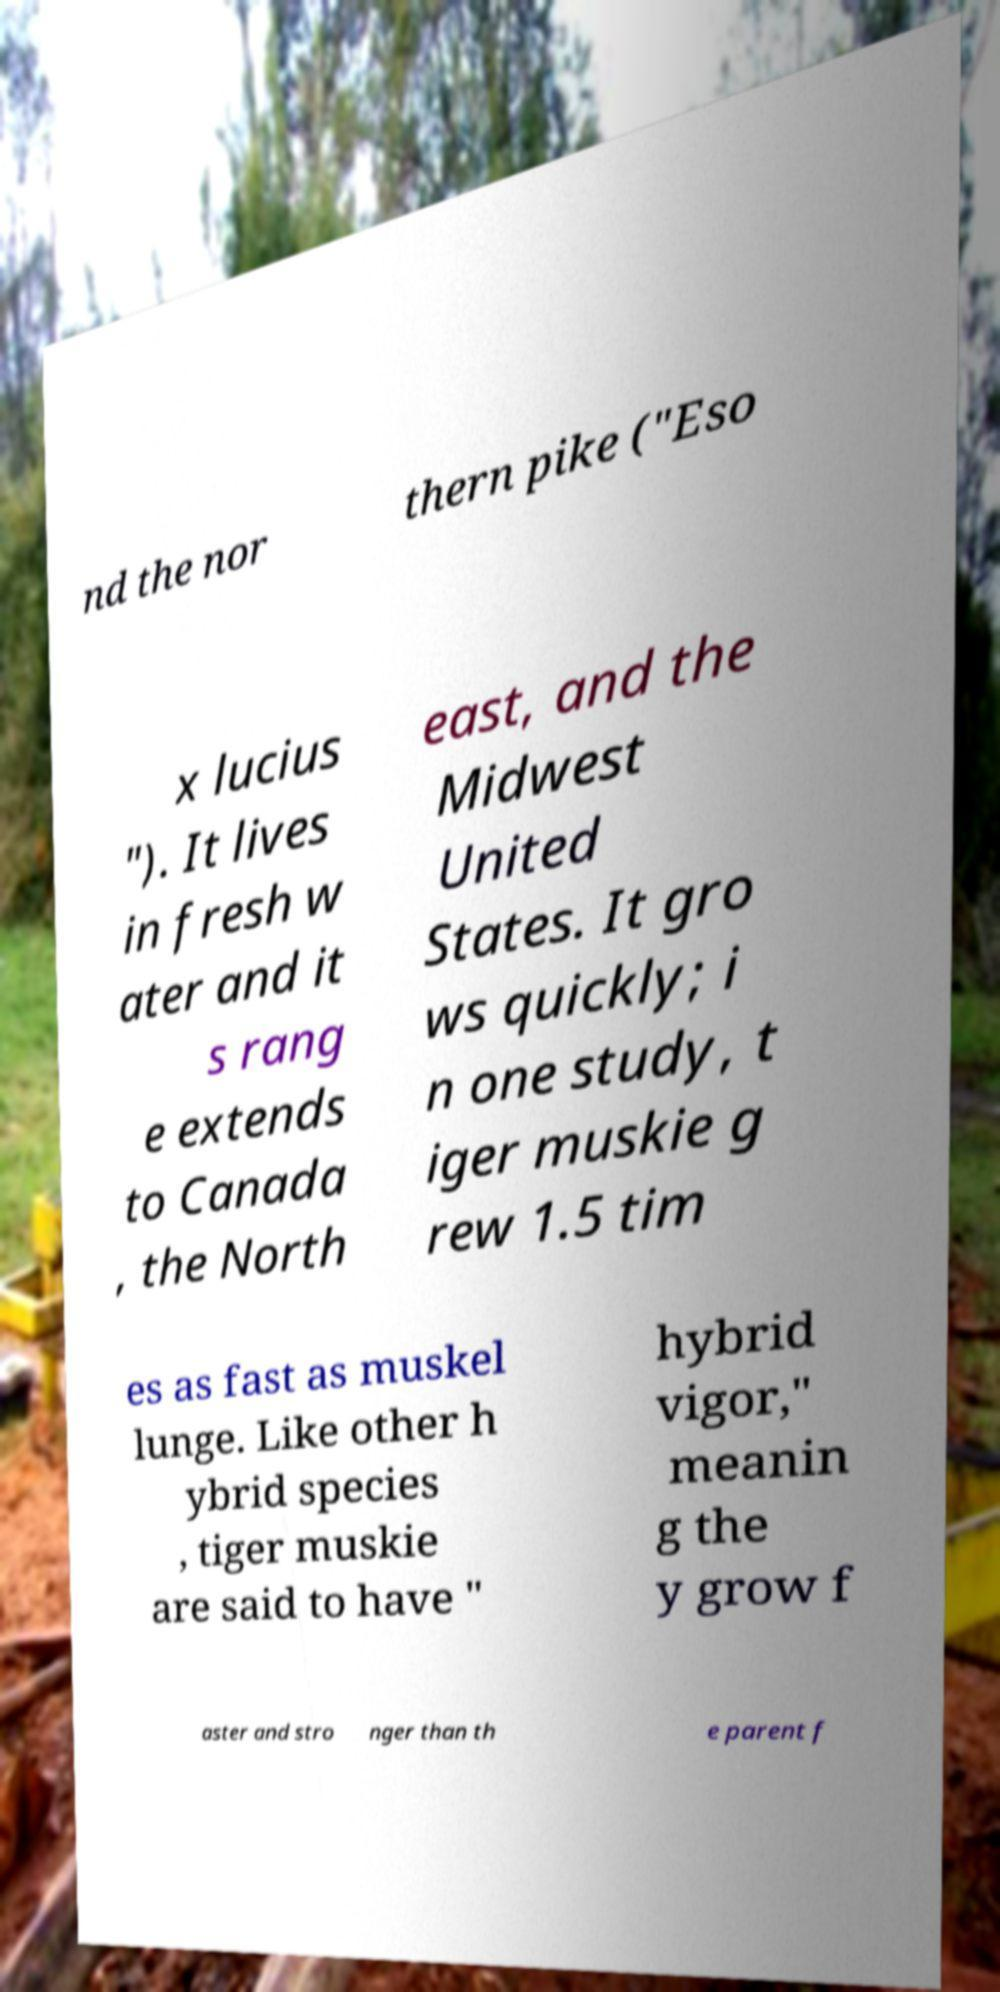Can you read and provide the text displayed in the image?This photo seems to have some interesting text. Can you extract and type it out for me? nd the nor thern pike ("Eso x lucius "). It lives in fresh w ater and it s rang e extends to Canada , the North east, and the Midwest United States. It gro ws quickly; i n one study, t iger muskie g rew 1.5 tim es as fast as muskel lunge. Like other h ybrid species , tiger muskie are said to have " hybrid vigor," meanin g the y grow f aster and stro nger than th e parent f 